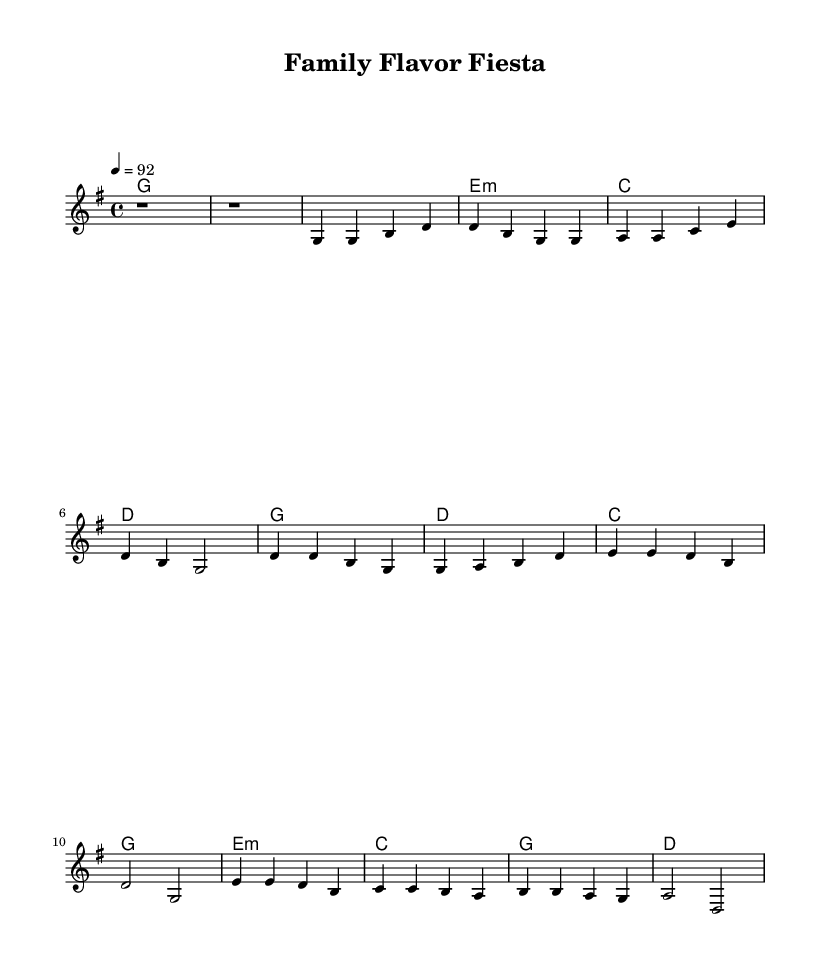What is the key signature of this music? The key signature shown at the beginning of the score indicates G major, which has one sharp (F#). This can be identified by looking at the key signature symbol at the beginning of the music.
Answer: G major What is the time signature of this music? The time signature is located near the beginning of the score and shows 4/4, which means there are four beats in each measure and a quarter note receives one beat.
Answer: 4/4 What is the tempo marking of this music? The tempo is indicated with "4 = 92," suggesting that there are 92 beats per minute, with each beat represented by a quarter note. This can be found at the top of the score in the tempo marking section.
Answer: 92 How many measures are in the verse section? The verse section in the melody lasts for 4 measures, which can be counted from the beginning of the verse to the end. It starts after the intro and contains four groups of notes.
Answer: 4 What type of chords are used in the bridge section? The bridge includes minor and major chords, specified in the chord symbols. In this section, e minor, c major, g major, and d major are used, as indicated in the harmonies.
Answer: Minor and major What chord follows the first measure of the chorus? The chord that follows the first measure of the chorus section is d major. This corresponds to the harmonic structure provided in the chord changes after the melody notes for that measure.
Answer: D What is the function of the intro in this piece? The intro serves as a lead-in to establish the key and feel before the verse begins, creating an inviting atmosphere. It sets the stage for the melody that follows, engaging listeners right from the start.
Answer: Lead-in 